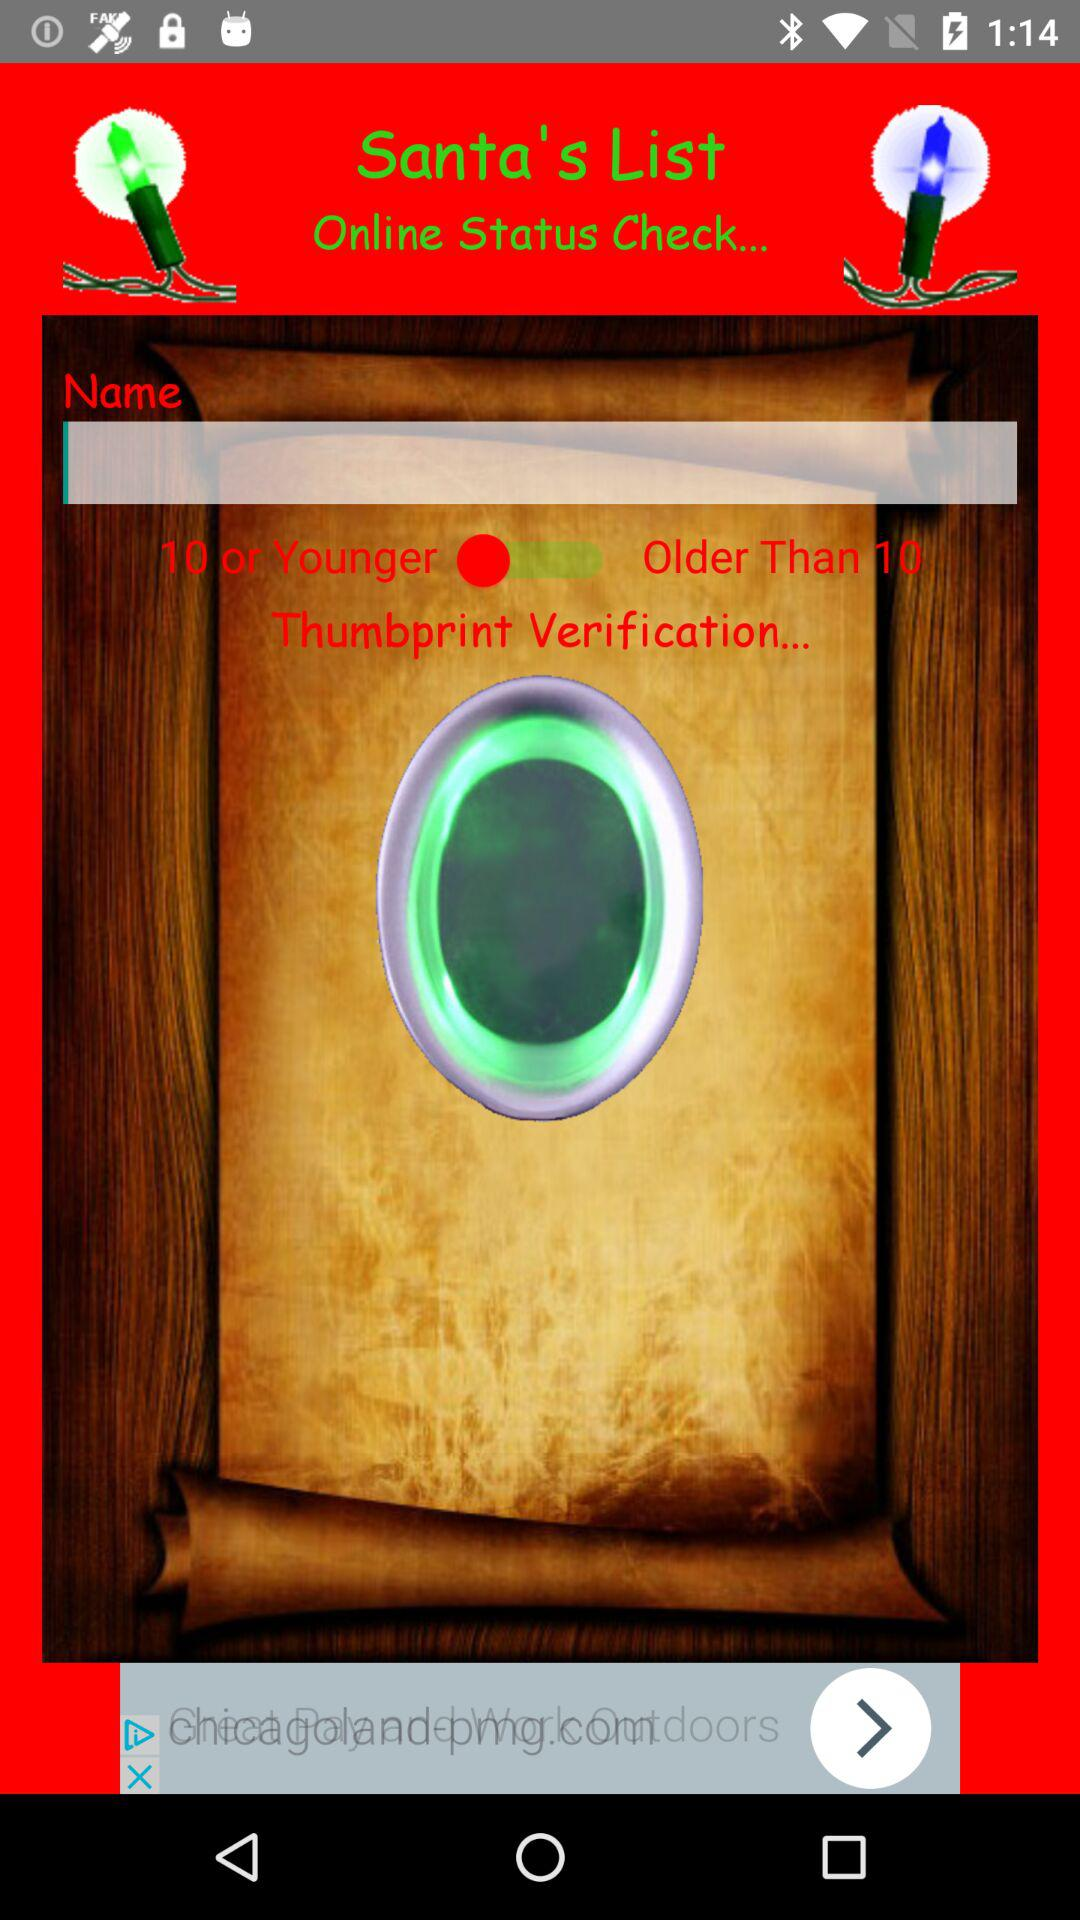What age range does the age bar show? The shown age ranges are "10 or Younger" and "Older Than 10". 